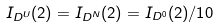<formula> <loc_0><loc_0><loc_500><loc_500>I _ { D ^ { U } } ( 2 ) = I _ { D ^ { N } } ( 2 ) = I _ { D ^ { 0 } } ( 2 ) / 1 0</formula> 